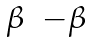Convert formula to latex. <formula><loc_0><loc_0><loc_500><loc_500>\begin{matrix} \beta & - \beta \end{matrix}</formula> 